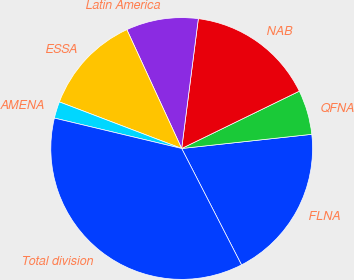<chart> <loc_0><loc_0><loc_500><loc_500><pie_chart><fcel>FLNA<fcel>QFNA<fcel>NAB<fcel>Latin America<fcel>ESSA<fcel>AMENA<fcel>Total division<nl><fcel>19.17%<fcel>5.49%<fcel>15.75%<fcel>8.91%<fcel>12.33%<fcel>2.06%<fcel>36.29%<nl></chart> 